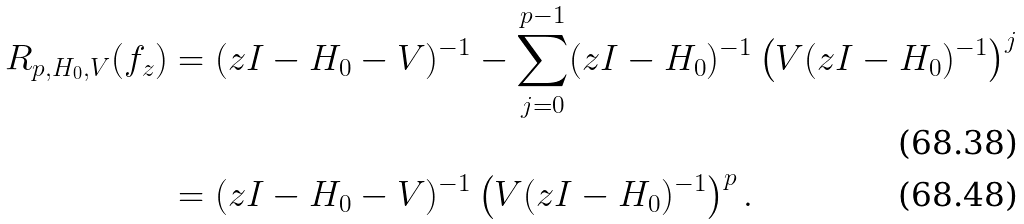Convert formula to latex. <formula><loc_0><loc_0><loc_500><loc_500>R _ { p , H _ { 0 } , V } ( f _ { z } ) & = ( z I - H _ { 0 } - V ) ^ { - 1 } - \sum _ { j = 0 } ^ { p - 1 } ( z I - H _ { 0 } ) ^ { - 1 } \left ( V ( z I - H _ { 0 } ) ^ { - 1 } \right ) ^ { j } \\ & = ( z I - H _ { 0 } - V ) ^ { - 1 } \left ( V ( z I - H _ { 0 } ) ^ { - 1 } \right ) ^ { p } .</formula> 